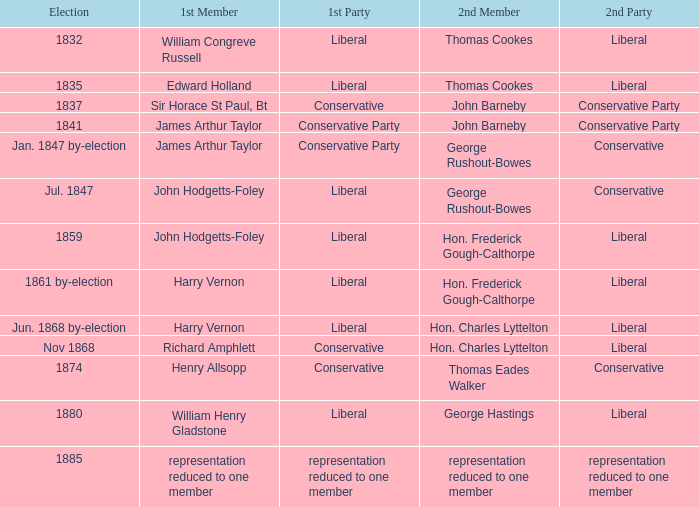What was the other party when its next member was george rushout-bowes, and the primary party was liberal? Conservative. 